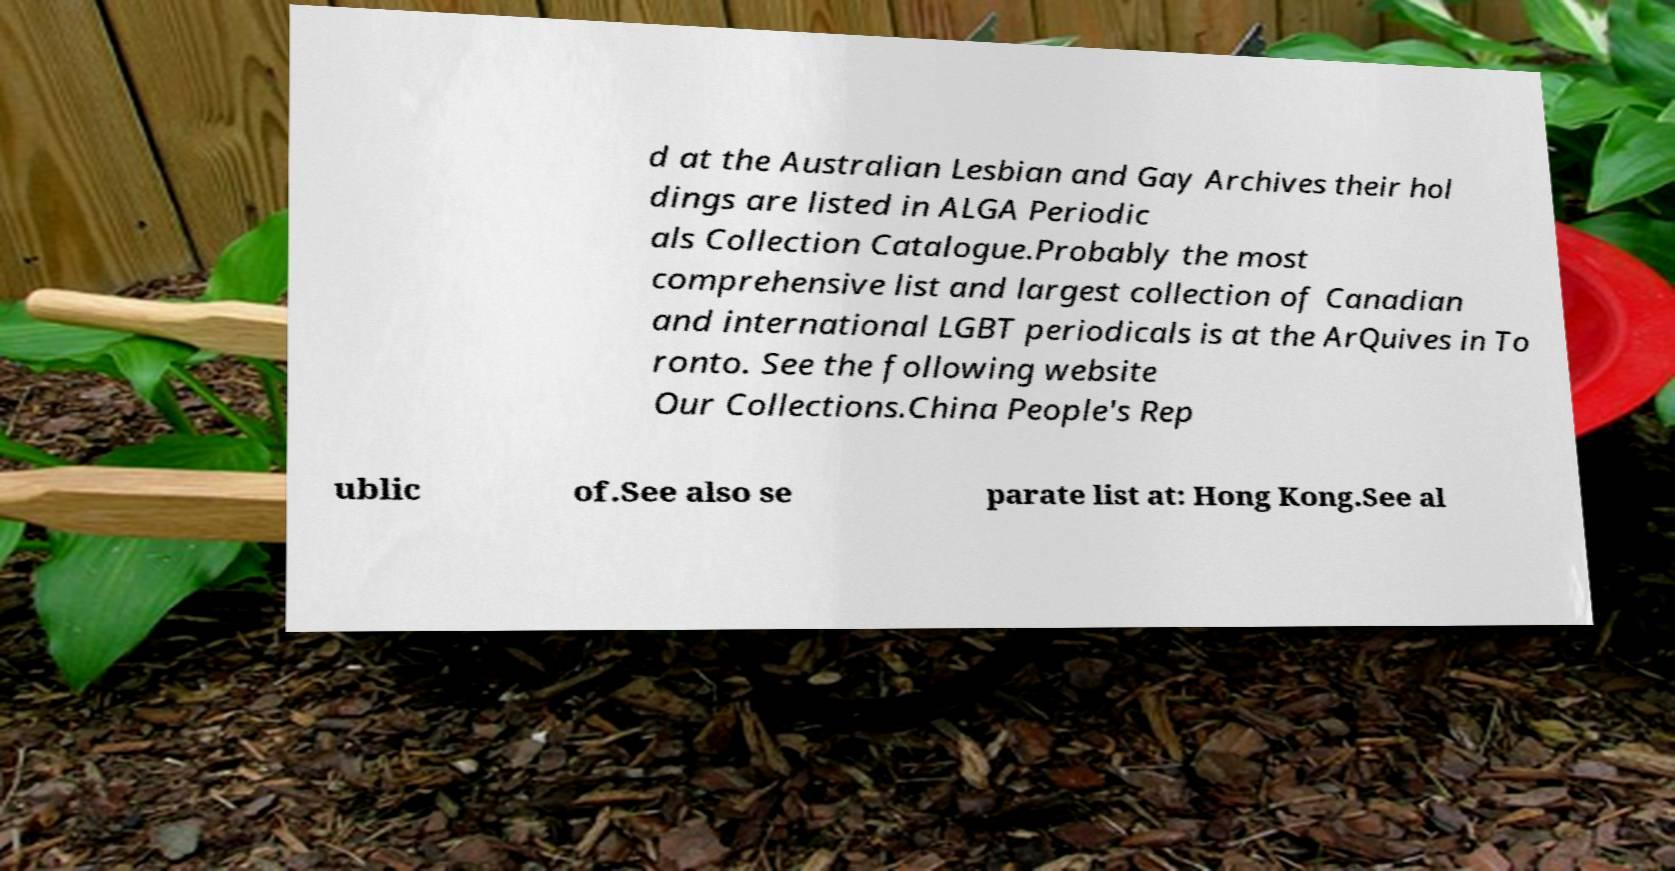What messages or text are displayed in this image? I need them in a readable, typed format. d at the Australian Lesbian and Gay Archives their hol dings are listed in ALGA Periodic als Collection Catalogue.Probably the most comprehensive list and largest collection of Canadian and international LGBT periodicals is at the ArQuives in To ronto. See the following website Our Collections.China People's Rep ublic of.See also se parate list at: Hong Kong.See al 